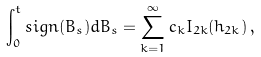<formula> <loc_0><loc_0><loc_500><loc_500>\int _ { 0 } ^ { t } s i g n ( B _ { s } ) d B _ { s } = \sum _ { k = 1 } ^ { \infty } c _ { k } I _ { 2 k } ( h _ { 2 k } ) \, ,</formula> 